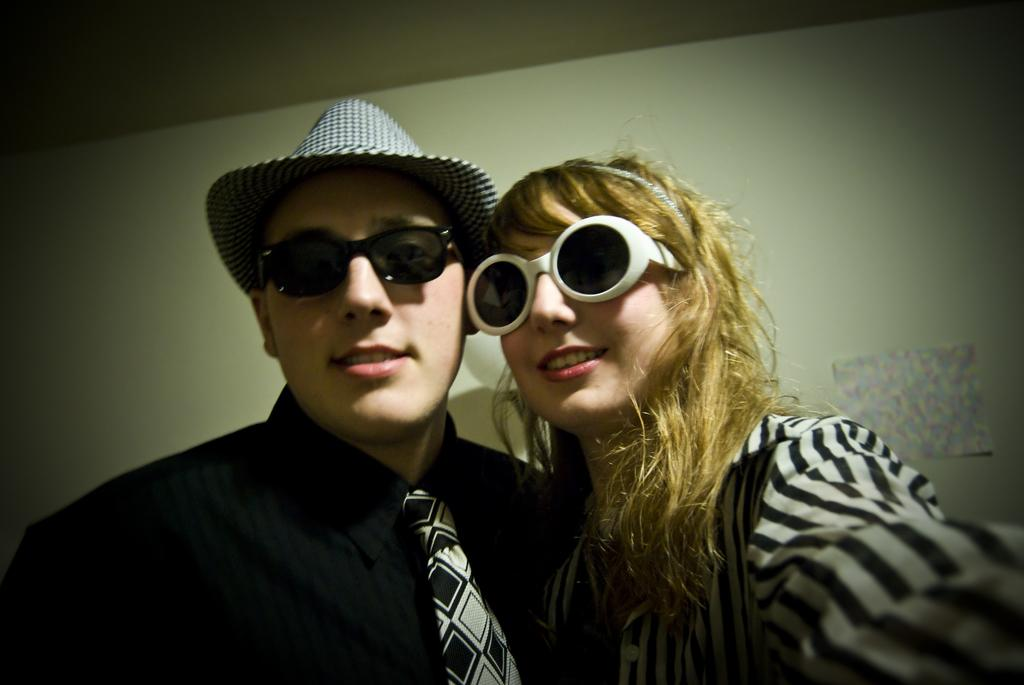How many people are present in the image? There are two people in the image, a woman and a man. What are the expressions of the people in the image? Both the woman and the man are smiling in the image. What are the people in the image doing? They are giving a pose for the picture. What can be seen in the background of the image? There is a wall in the background of the image. What is attached to the wall in the image? A paper is attached to the wall. How much pain can be seen on the woman's face in the image? There is no indication of pain on the woman's face in the image; she is smiling. What type of bait is being used by the man in the image? There is no bait present in the image; it features a woman and a man posing for a picture. 